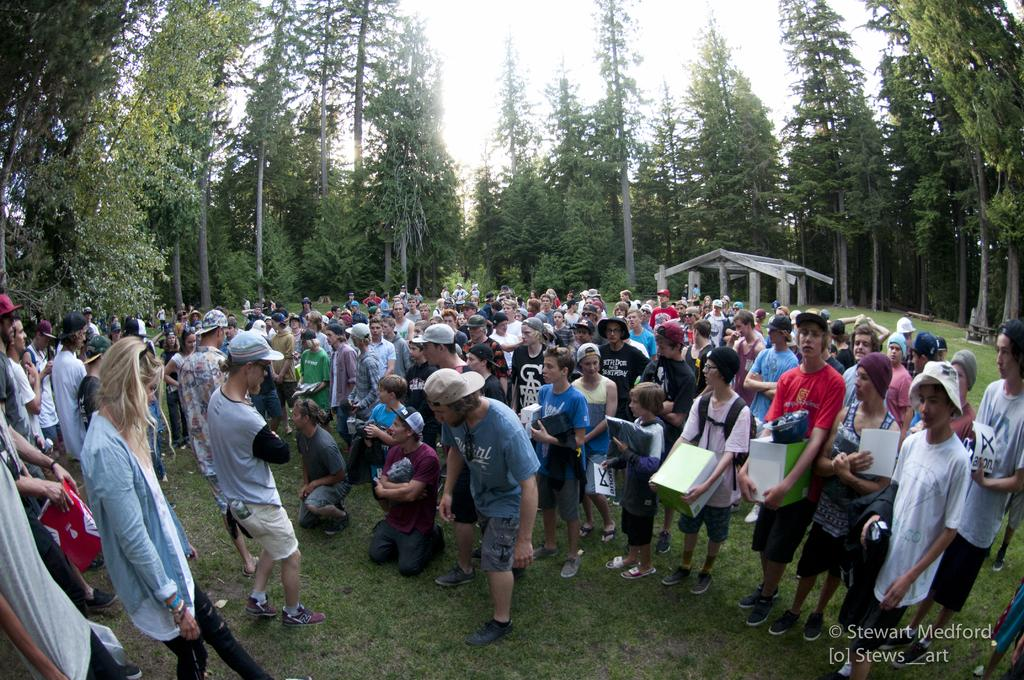What is the main subject of the image? The main subject of the image is a huge crowd. Where is the crowd located? The crowd is on a grass surface. What can be seen in the background of the image? There are tall trees around the crowd, and a shelter made up of wood in the background. What type of writing can be seen on the locket worn by someone in the crowd? There is no locket or writing present in the image; it features a huge crowd on a grass surface with tall trees and a wooden shelter in the background. 